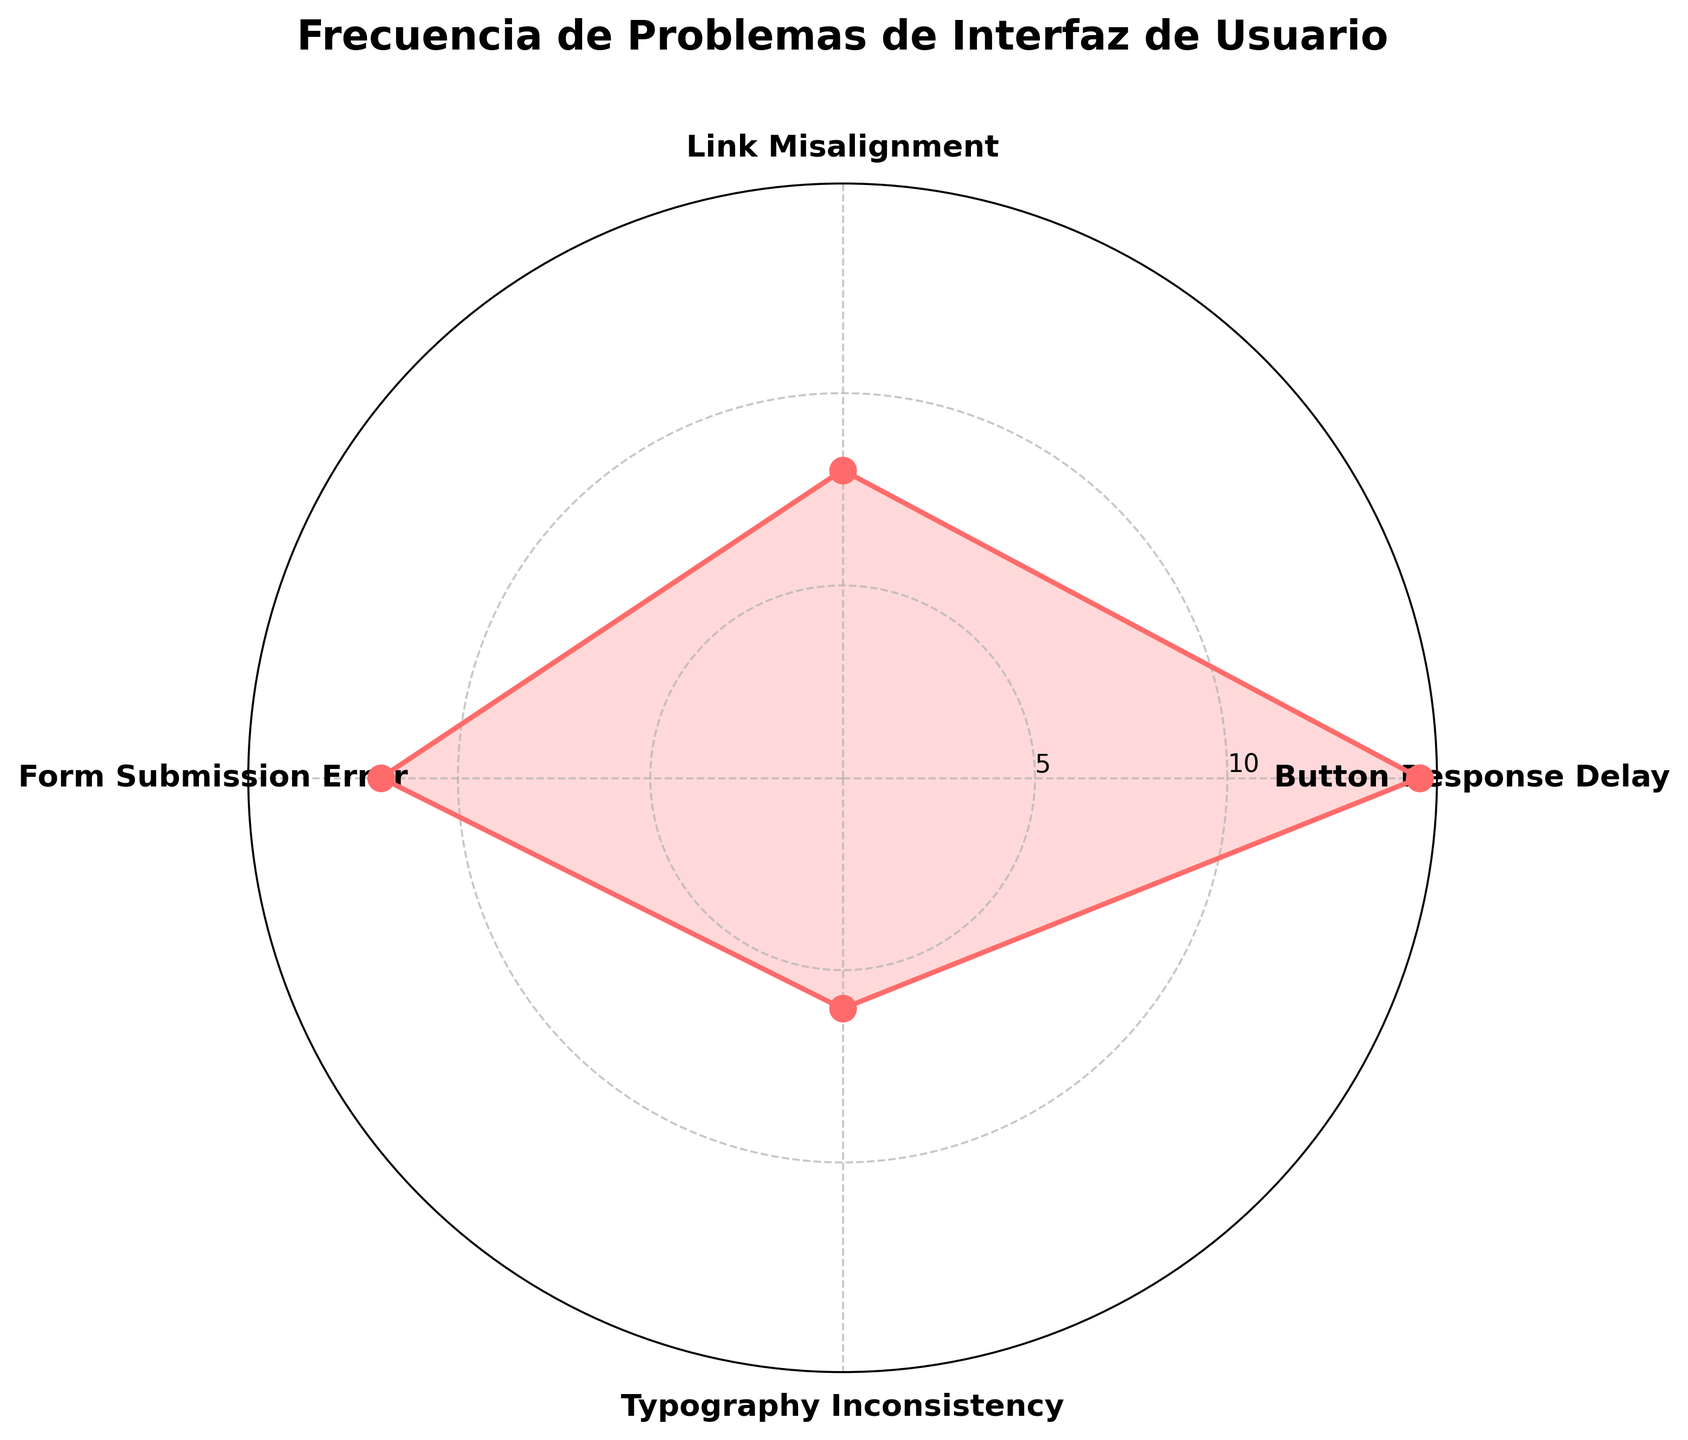What's the title of the plot? The title is prominently displayed at the top of the plot. It provides a clear summary of what the plot represents.
Answer: Frecuencia de Problemas de Interfaz de Usuario Which UI issue has the highest frequency? By observing the length of the spokes in the rose chart, we can identify which one reaches the farthest from the center.
Answer: Button Response Delay What is the frequency of the Link Misalignment issue? Locate the 'Link Misalignment' label and observe the corresponding length of the spoke indicating its frequency.
Answer: 8 What is the difference in frequency between Button Response Delay and Typography Inconsistency? Subtract the frequency of Typography Inconsistency from the frequency of Button Response Delay.
Answer: 9 Which issue has the lowest occurrence? Find the shortest spoke in the rose chart and look at its label.
Answer: Typography Inconsistency How many issues have frequencies greater than 10? Count the number of spokes that extend beyond the 10 mark on the y-axis.
Answer: 2 What is the average frequency of all issues? Sum the frequencies of all issues and divide by the total number of issues (15 + 8 + 12 + 6 = 41; 41/4).
Answer: 10.25 Which issue has a frequency equal to half of the Button Response Delay? Find the frequency of Button Response Delay (15) and locate the issue with a frequency of 15/2 = 7.5. No issue has exactly 7.5, so identify the closest.
Answer: None If we combined the frequencies of Link Misalignment and Typography Inconsistency, would they exceed the frequency of Form Submission Error? Add the frequencies of Link Misalignment (8) and Typography Inconsistency (6); compare the sum to the frequency of Form Submission Error (12). 8 + 6 = 14, which is greater than 12.
Answer: Yes 